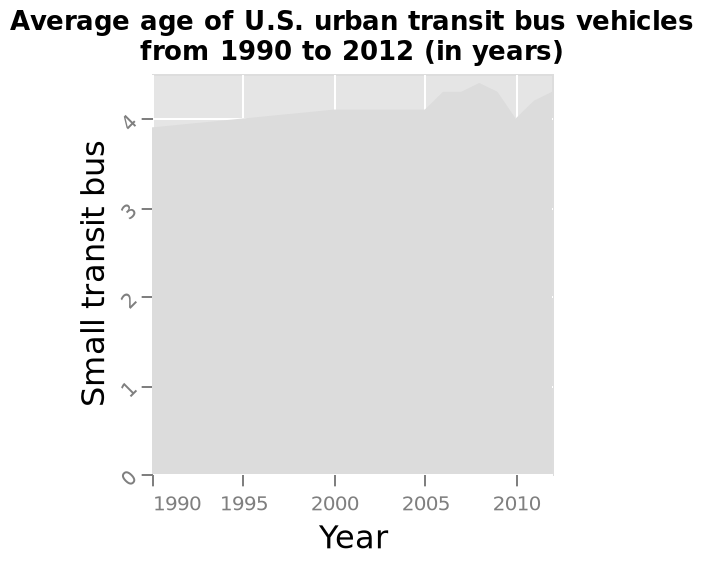<image>
please enumerates aspects of the construction of the chart Average age of U.S. urban transit bus vehicles from 1990 to 2012 (in years) is a area plot. The x-axis shows Year as linear scale of range 1990 to 2010 while the y-axis shows Small transit bus using linear scale from 0 to 4. Does the bar graph represent the average age of U.S. urban transit bus vehicles from 1990 to 2012? No.Average age of U.S. urban transit bus vehicles from 1990 to 2012 (in years) is a area plot. The x-axis shows Year as linear scale of range 1990 to 2010 while the y-axis shows Small transit bus using linear scale from 0 to 4. 